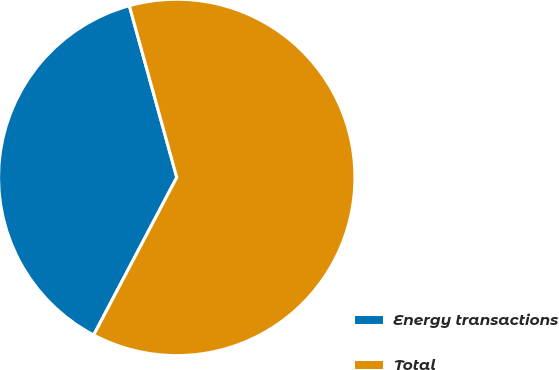<chart> <loc_0><loc_0><loc_500><loc_500><pie_chart><fcel>Energy transactions<fcel>Total<nl><fcel>37.99%<fcel>62.01%<nl></chart> 